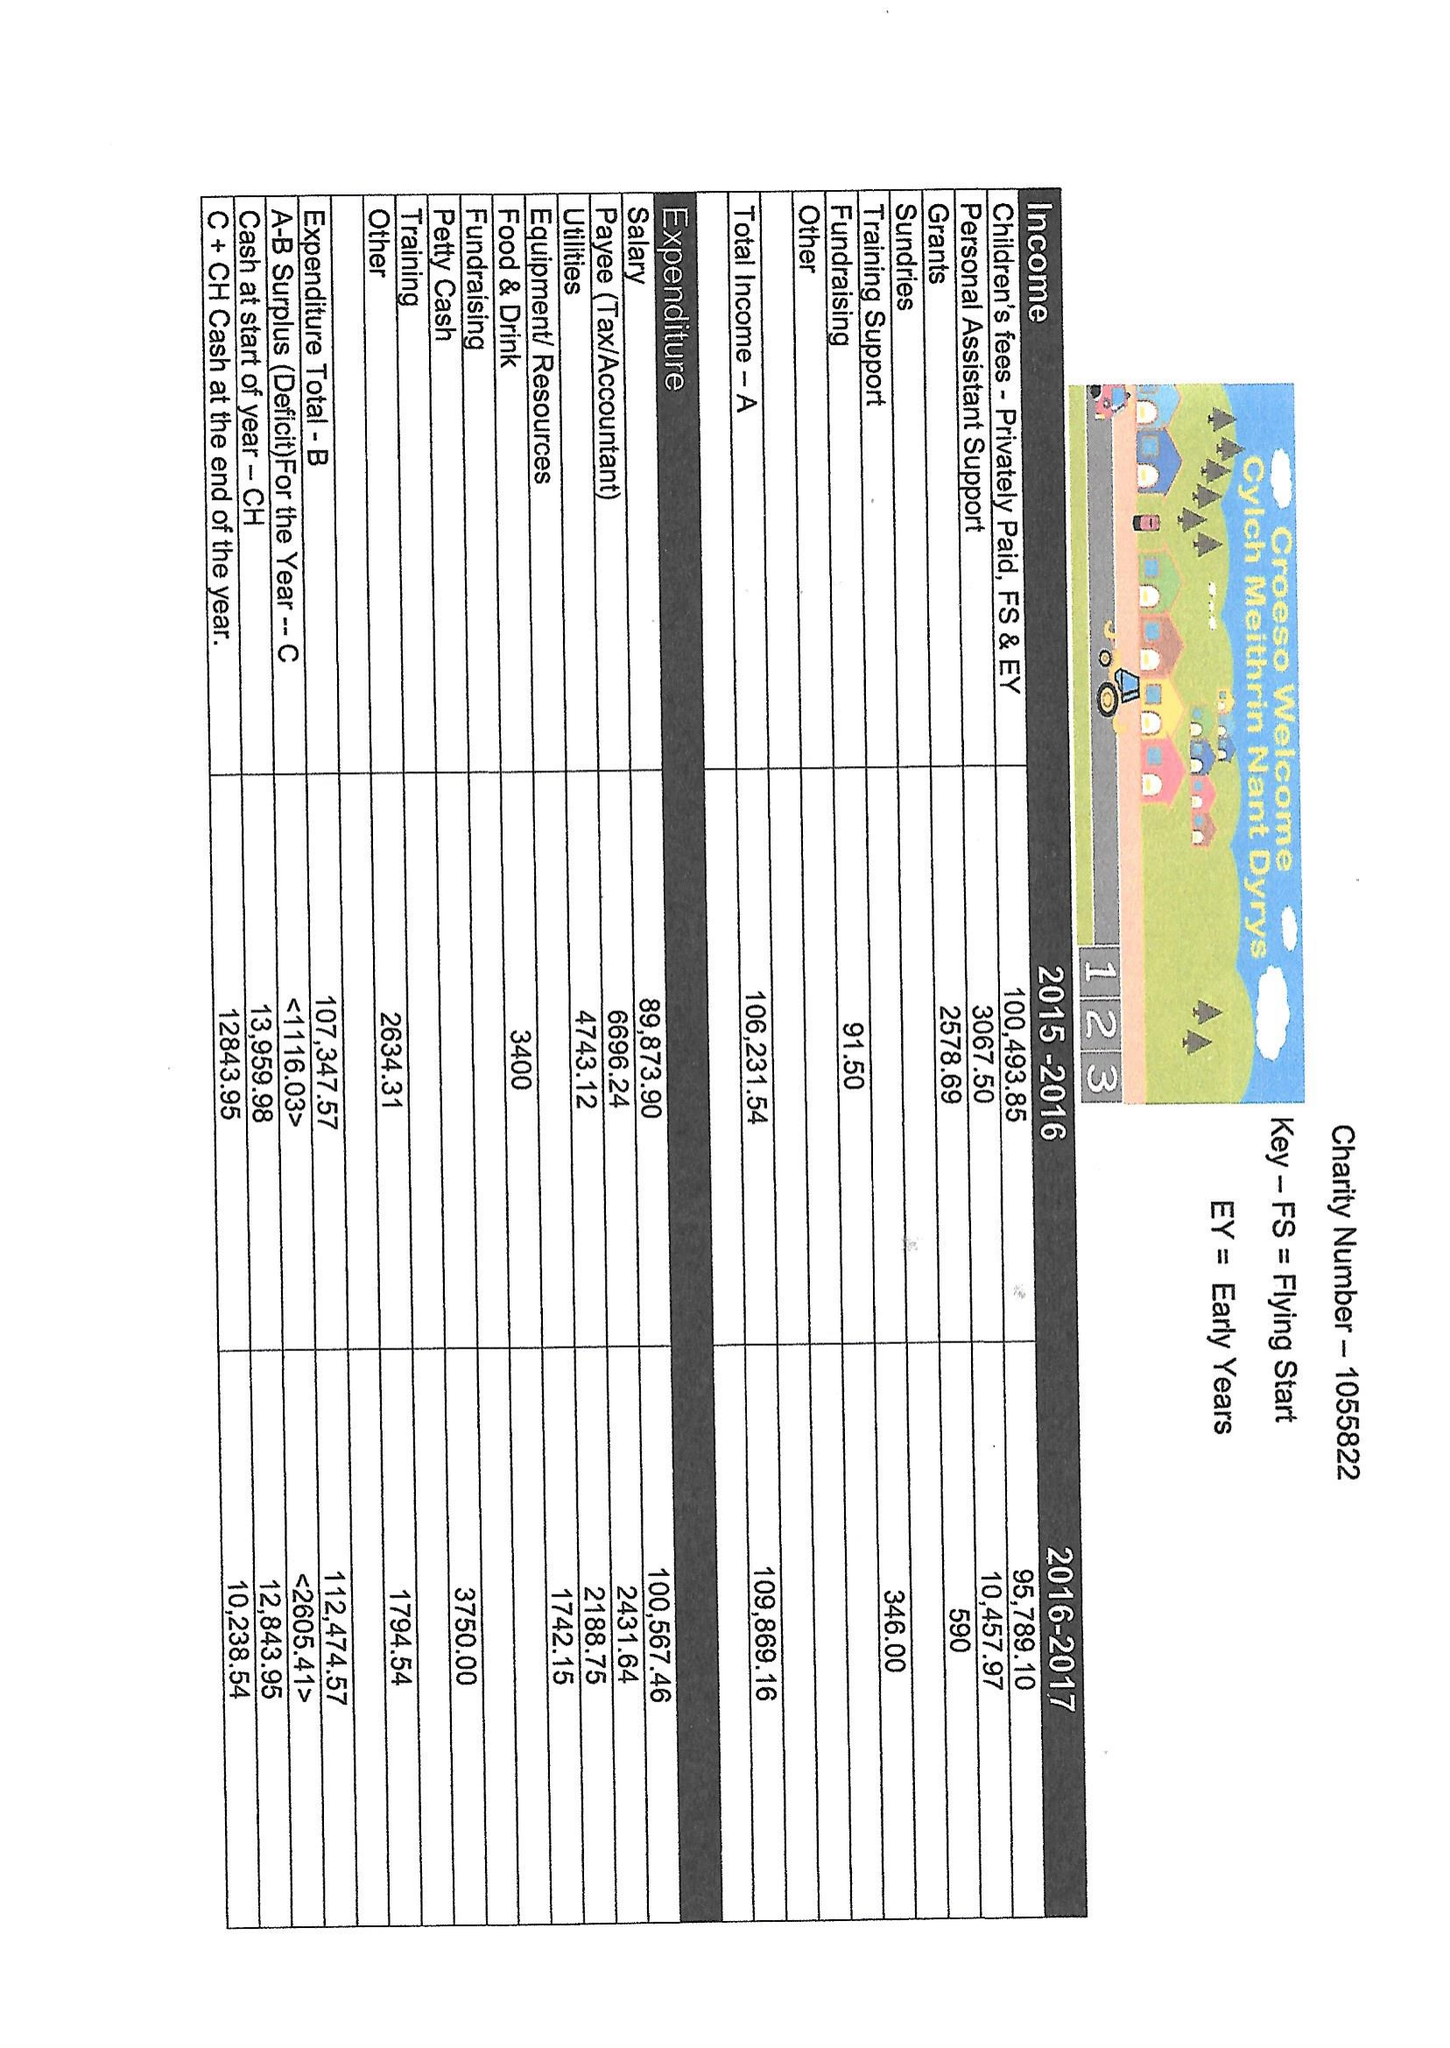What is the value for the address__street_line?
Answer the question using a single word or phrase. CLINIC ROAD 